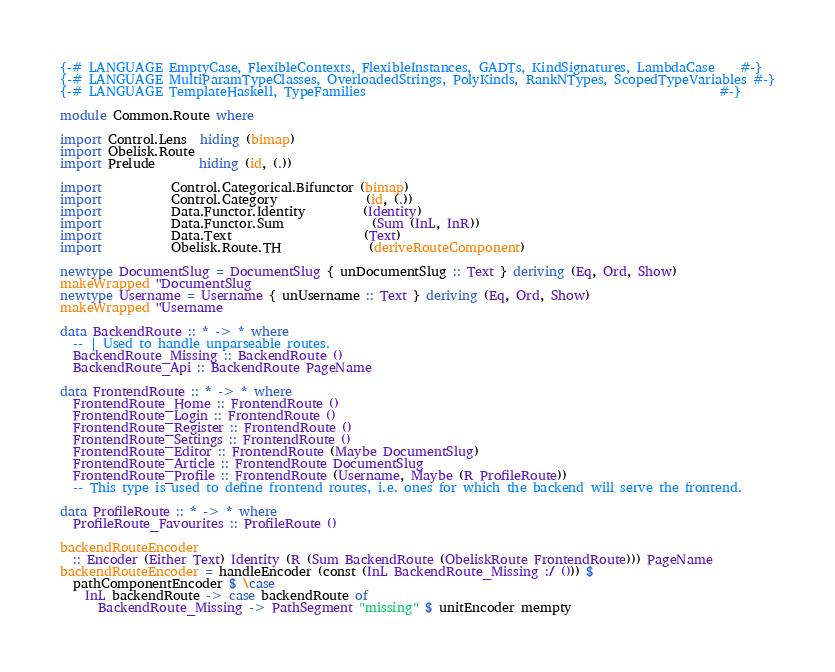<code> <loc_0><loc_0><loc_500><loc_500><_Haskell_>{-# LANGUAGE EmptyCase, FlexibleContexts, FlexibleInstances, GADTs, KindSignatures, LambdaCase    #-}
{-# LANGUAGE MultiParamTypeClasses, OverloadedStrings, PolyKinds, RankNTypes, ScopedTypeVariables #-}
{-# LANGUAGE TemplateHaskell, TypeFamilies                                                        #-}

module Common.Route where

import Control.Lens  hiding (bimap)
import Obelisk.Route
import Prelude       hiding (id, (.))

import           Control.Categorical.Bifunctor (bimap)
import           Control.Category              (id, (.))
import           Data.Functor.Identity         (Identity)
import           Data.Functor.Sum              (Sum (InL, InR))
import           Data.Text                     (Text)
import           Obelisk.Route.TH              (deriveRouteComponent)

newtype DocumentSlug = DocumentSlug { unDocumentSlug :: Text } deriving (Eq, Ord, Show)
makeWrapped ''DocumentSlug
newtype Username = Username { unUsername :: Text } deriving (Eq, Ord, Show)
makeWrapped ''Username

data BackendRoute :: * -> * where
  -- | Used to handle unparseable routes.
  BackendRoute_Missing :: BackendRoute ()
  BackendRoute_Api :: BackendRoute PageName

data FrontendRoute :: * -> * where
  FrontendRoute_Home :: FrontendRoute ()
  FrontendRoute_Login :: FrontendRoute ()
  FrontendRoute_Register :: FrontendRoute ()
  FrontendRoute_Settings :: FrontendRoute ()
  FrontendRoute_Editor :: FrontendRoute (Maybe DocumentSlug)
  FrontendRoute_Article :: FrontendRoute DocumentSlug
  FrontendRoute_Profile :: FrontendRoute (Username, Maybe (R ProfileRoute))
  -- This type is used to define frontend routes, i.e. ones for which the backend will serve the frontend.

data ProfileRoute :: * -> * where
  ProfileRoute_Favourites :: ProfileRoute ()

backendRouteEncoder
  :: Encoder (Either Text) Identity (R (Sum BackendRoute (ObeliskRoute FrontendRoute))) PageName
backendRouteEncoder = handleEncoder (const (InL BackendRoute_Missing :/ ())) $
  pathComponentEncoder $ \case
    InL backendRoute -> case backendRoute of
      BackendRoute_Missing -> PathSegment "missing" $ unitEncoder mempty</code> 